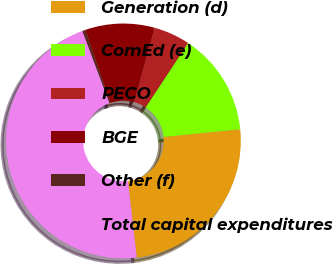<chart> <loc_0><loc_0><loc_500><loc_500><pie_chart><fcel>Generation (d)<fcel>ComEd (e)<fcel>PECO<fcel>BGE<fcel>Other (f)<fcel>Total capital expenditures<nl><fcel>24.79%<fcel>14.13%<fcel>4.99%<fcel>9.56%<fcel>0.42%<fcel>46.12%<nl></chart> 